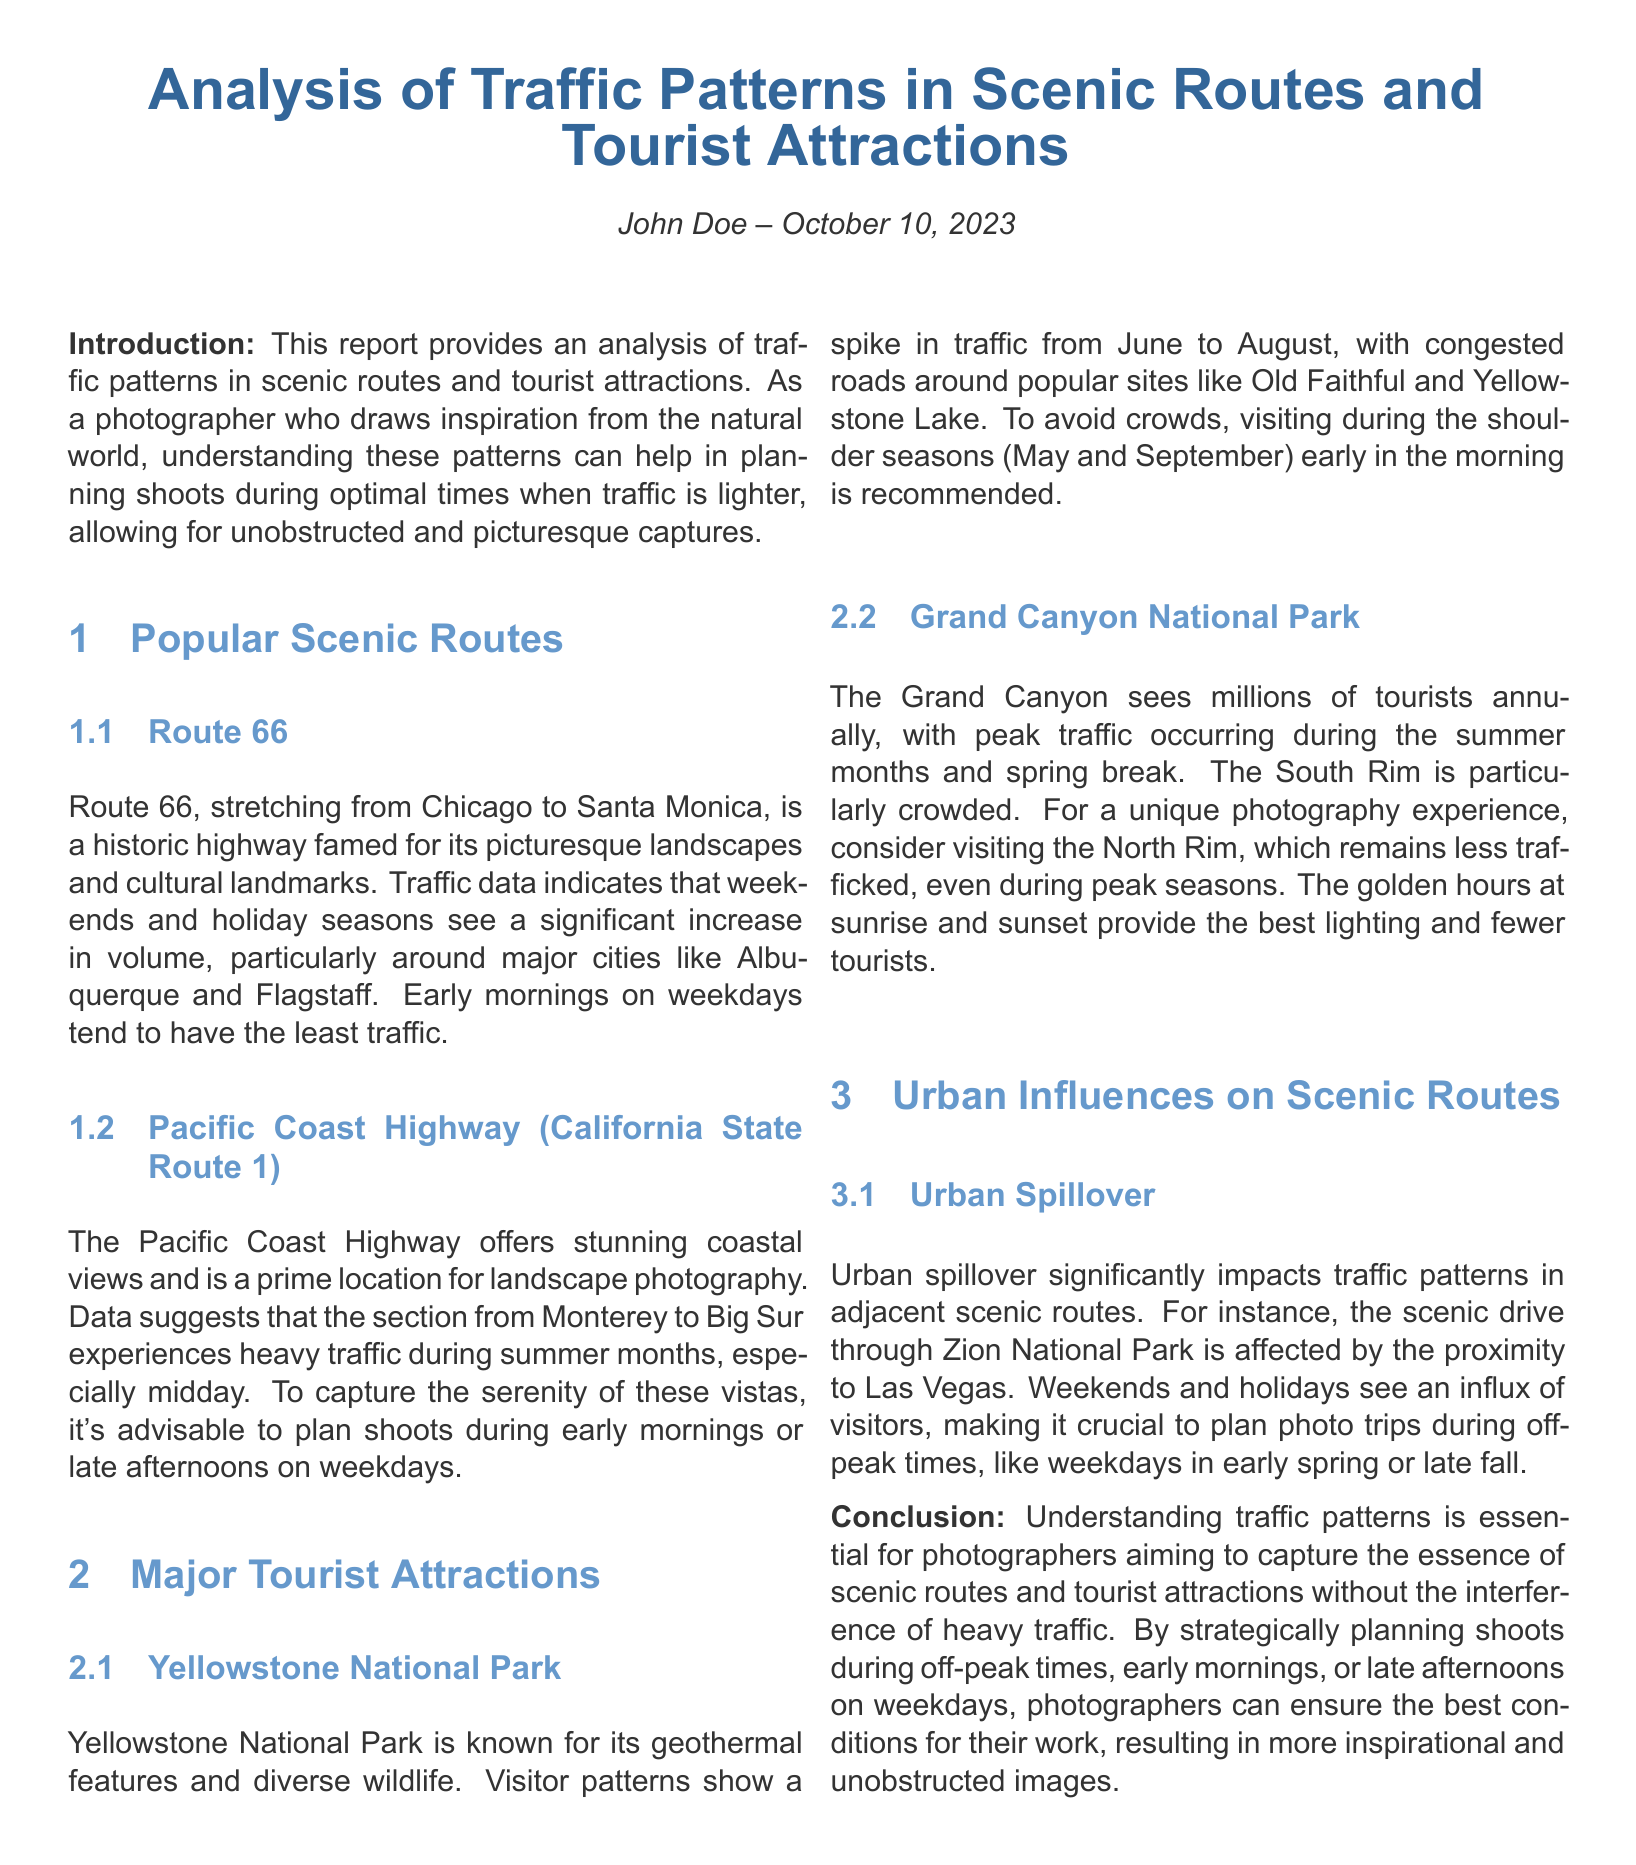what is the author's name? The author's name is mentioned at the top of the document for attribution of the report.
Answer: John Doe when is the peak traffic season for Yellowstone National Park? The document states that the peak traffic season for Yellowstone occurs from June to August.
Answer: June to August what is the recommended time to shoot on the Pacific Coast Highway? The report suggests that the best times for shooting photographs on this highway are early mornings or late afternoons on weekdays.
Answer: Early mornings or late afternoons on weekdays which scenic route is influenced by Las Vegas? The document discusses urban spillover effects from Las Vegas, impacting the traffic patterns of Zion National Park's scenic drive.
Answer: Zion National Park what is a less crowded time to visit the Grand Canyon? The document recommends visiting the North Rim for a less crowded experience, even during peak seasons.
Answer: North Rim what feature is Yellowstone National Park known for? Yellowstone is noted for its geothermal features and diverse wildlife, highlighting its natural attractions.
Answer: Geothermal features which route experiences heavy traffic during summer months? The report identifies the Pacific Coast Highway, specifically the section from Monterey to Big Sur, as experiencing heavy traffic in summer.
Answer: Pacific Coast Highway what is the ideal visiting time for avoiding crowds in Yellowstone? The document advises visiting during early morning in the shoulder seasons (May and September) to avoid crowds.
Answer: Early morning in May and September 